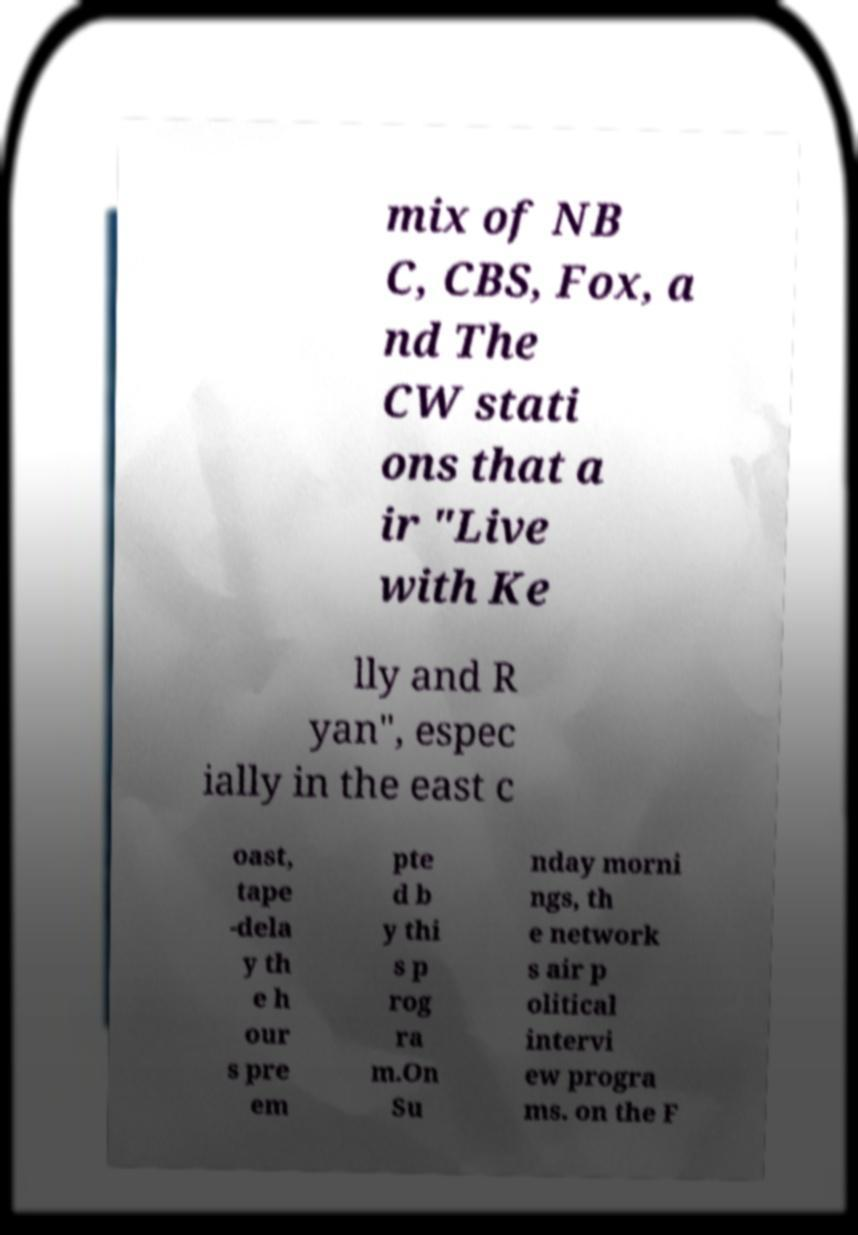Please identify and transcribe the text found in this image. mix of NB C, CBS, Fox, a nd The CW stati ons that a ir "Live with Ke lly and R yan", espec ially in the east c oast, tape -dela y th e h our s pre em pte d b y thi s p rog ra m.On Su nday morni ngs, th e network s air p olitical intervi ew progra ms. on the F 